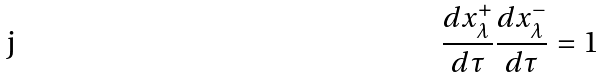Convert formula to latex. <formula><loc_0><loc_0><loc_500><loc_500>\frac { d x ^ { + } _ { \lambda } } { d \tau } \frac { d x ^ { - } _ { \lambda } } { d \tau } = 1</formula> 